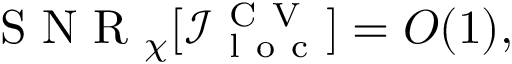<formula> <loc_0><loc_0><loc_500><loc_500>S N R _ { \chi } [ \mathcal { I } _ { l o c } ^ { C V } ] = O ( 1 ) ,</formula> 